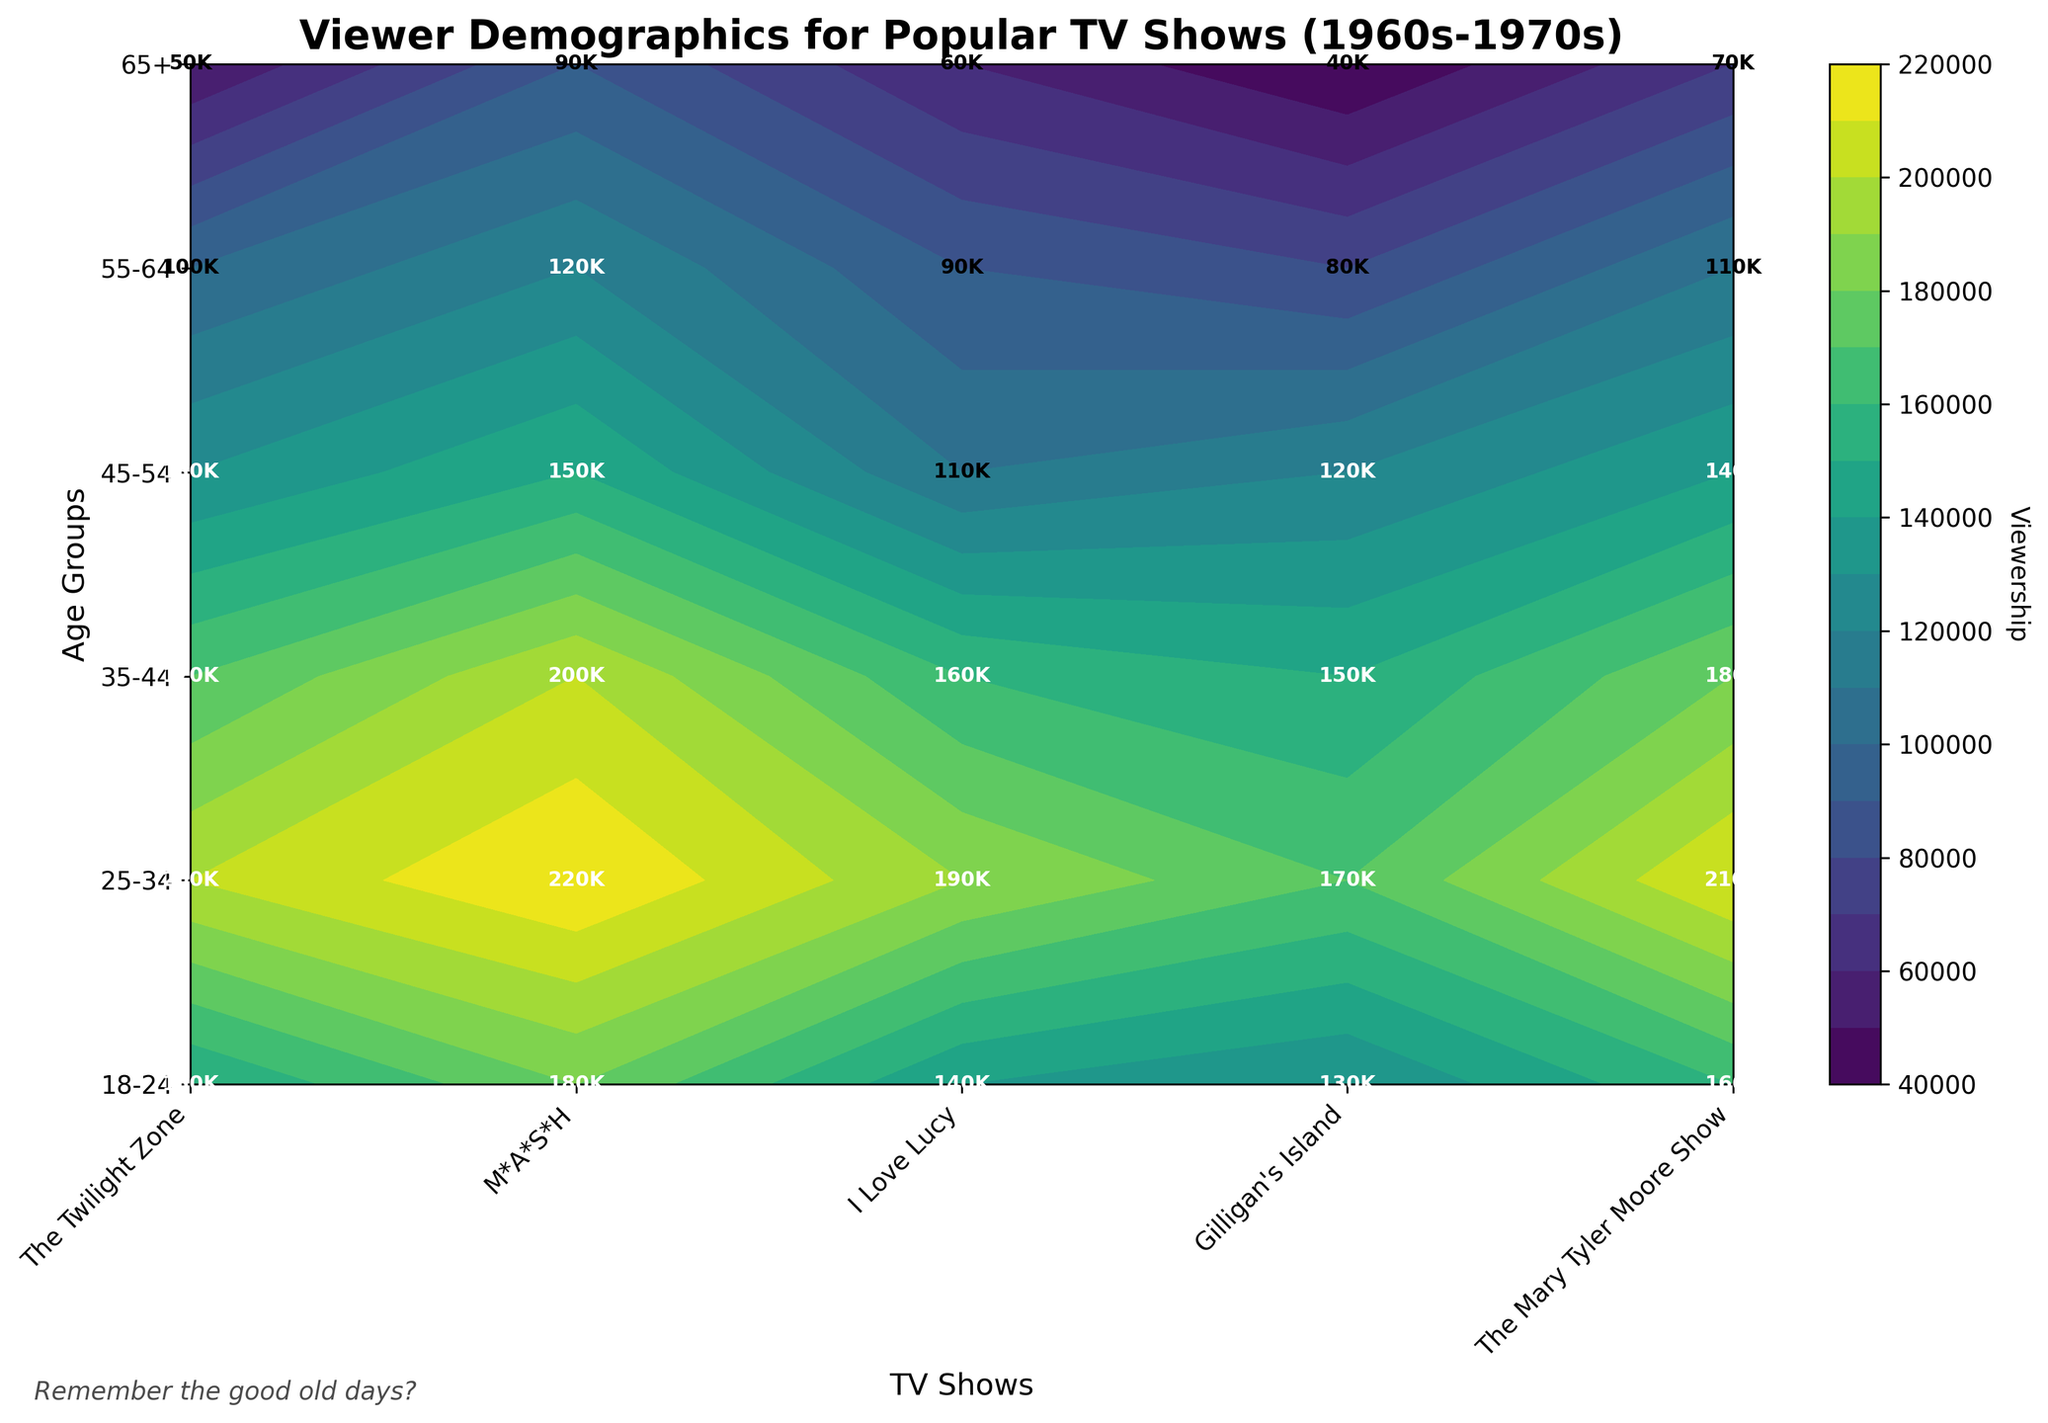Which TV show has the highest viewership for the 18-24 age group? By examining the 18-24 row and looking for the highest viewership value, we find that "M*A*S*H" in California has the highest viewership at this age group.
Answer: M*A*S*H What is the difference in viewership between the 25-34 and 65+ age groups for "I Love Lucy"? To find the difference, look at "I Love Lucy" in Texas for the 25-34 age group (190,000 viewers) and the 65+ age group (60,000 viewers), then subtract the smaller number from the larger one: 190,000 - 60,000.
Answer: 130,000 Which age group shows the most consistent increase or decrease in viewership for "The Twilight Zone" across all geographical locations? Looking at "The Twilight Zone" in New York across all age groups, we notice that viewership consistently decreases from 18-24 (150,000) to 65+ (50,000) age group.
Answer: 18-24 to 65+ How many total viewers does "The Mary Tyler Moore Show" attract across all age groups in Illinois? Add the viewership numbers for all age groups in Illinois for "The Mary Tyler Moore Show": 160,000 + 210,000 + 180,000 + 140,000 + 110,000 + 70,000.
Answer: 870,000 Is there any age group where "Gilligan's Island" in Florida has more viewership than "The Twilight Zone" in New York? Compare the viewership numbers for "Gilligan's Island" in Florida and "The Twilight Zone" in New York across all age groups. The viewership of "Gilligan's Island" never exceeds that of "The Twilight Zone" in any age group.
Answer: No Which show has the highest viewership for the 25-34 age group? Compare the viewership numbers for all shows in the 25-34 age group: The Twilight Zone (200,000), M*A*S*H (220,000), I Love Lucy (190,000), Gilligan's Island (170,000), and The Mary Tyler Moore Show (210,000). M*A*S*H has the highest viewership in this group.
Answer: M*A*S*H What is the average viewership for the 35-44 age group across all shows? To find the average, add the viewership numbers for the 35-44 age group across all shows and divide by the number of shows: (170,000 + 200,000 + 160,000 + 150,000 + 180,000) / 5.
Answer: 172,000 Does the viewership for "The Mary Tyler Moore Show" increase or decrease as the age group goes up? By analyzing the viewership values for "The Mary Tyler Moore Show" in Illinois from 18-24 (160,000), 25-34 (210,000), 35-44 (180,000), 45-54 (140,000), 55-64 (110,000), to 65+ (70,000), we can see an initial increase followed by a steady decrease.
Answer: Initial increase, then decrease 